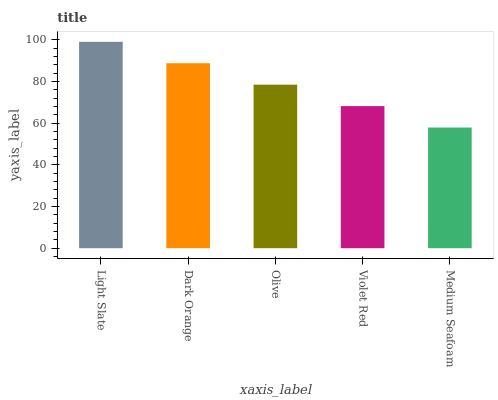Is Dark Orange the minimum?
Answer yes or no. No. Is Dark Orange the maximum?
Answer yes or no. No. Is Light Slate greater than Dark Orange?
Answer yes or no. Yes. Is Dark Orange less than Light Slate?
Answer yes or no. Yes. Is Dark Orange greater than Light Slate?
Answer yes or no. No. Is Light Slate less than Dark Orange?
Answer yes or no. No. Is Olive the high median?
Answer yes or no. Yes. Is Olive the low median?
Answer yes or no. Yes. Is Violet Red the high median?
Answer yes or no. No. Is Medium Seafoam the low median?
Answer yes or no. No. 